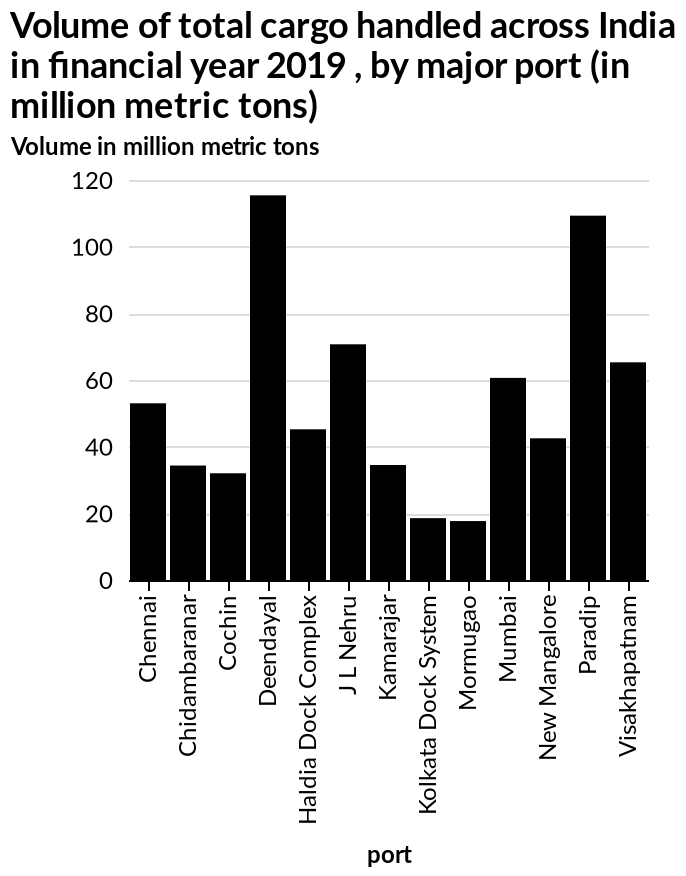<image>
How much cargo did Mormugao handle? Mormugao handled the least amount of cargo, with just about 19 million tonnes. What is the unit of measurement for the volume shown on the bar graph? The unit of measurement for the volume shown on the bar graph is million metric tons. Offer a thorough analysis of the image. Deendayal handed by far the most cargo, approximately 118 million tonnes, 2nd was paradise with roughly 114 million tonnes. Mormugao was the port handling the least with just about 19 million tonnes. Did Mormugao handle the highest amount of cargo, with just about 19 million tonnes? No.Mormugao handled the least amount of cargo, with just about 19 million tonnes. 